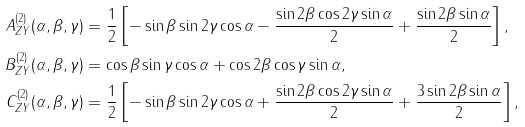<formula> <loc_0><loc_0><loc_500><loc_500>A _ { Z Y } ^ { ( 2 ) } ( \alpha , \beta , \gamma ) & = \frac { 1 } { 2 } \left [ - \sin \beta \sin 2 \gamma \cos \alpha - \frac { \sin 2 \beta \cos 2 \gamma \sin \alpha } { 2 } + \frac { \sin 2 \beta \sin \alpha } { 2 } \right ] , \\ B _ { Z Y } ^ { ( 2 ) } ( \alpha , \beta , \gamma ) & = \cos \beta \sin \gamma \cos \alpha + \cos 2 \beta \cos \gamma \sin \alpha , \\ C _ { Z Y } ^ { ( 2 ) } ( \alpha , \beta , \gamma ) & = \frac { 1 } { 2 } \left [ - \sin \beta \sin 2 \gamma \cos \alpha + \frac { \sin 2 \beta \cos 2 \gamma \sin \alpha } { 2 } + \frac { 3 \sin 2 \beta \sin \alpha } { 2 } \right ] ,</formula> 